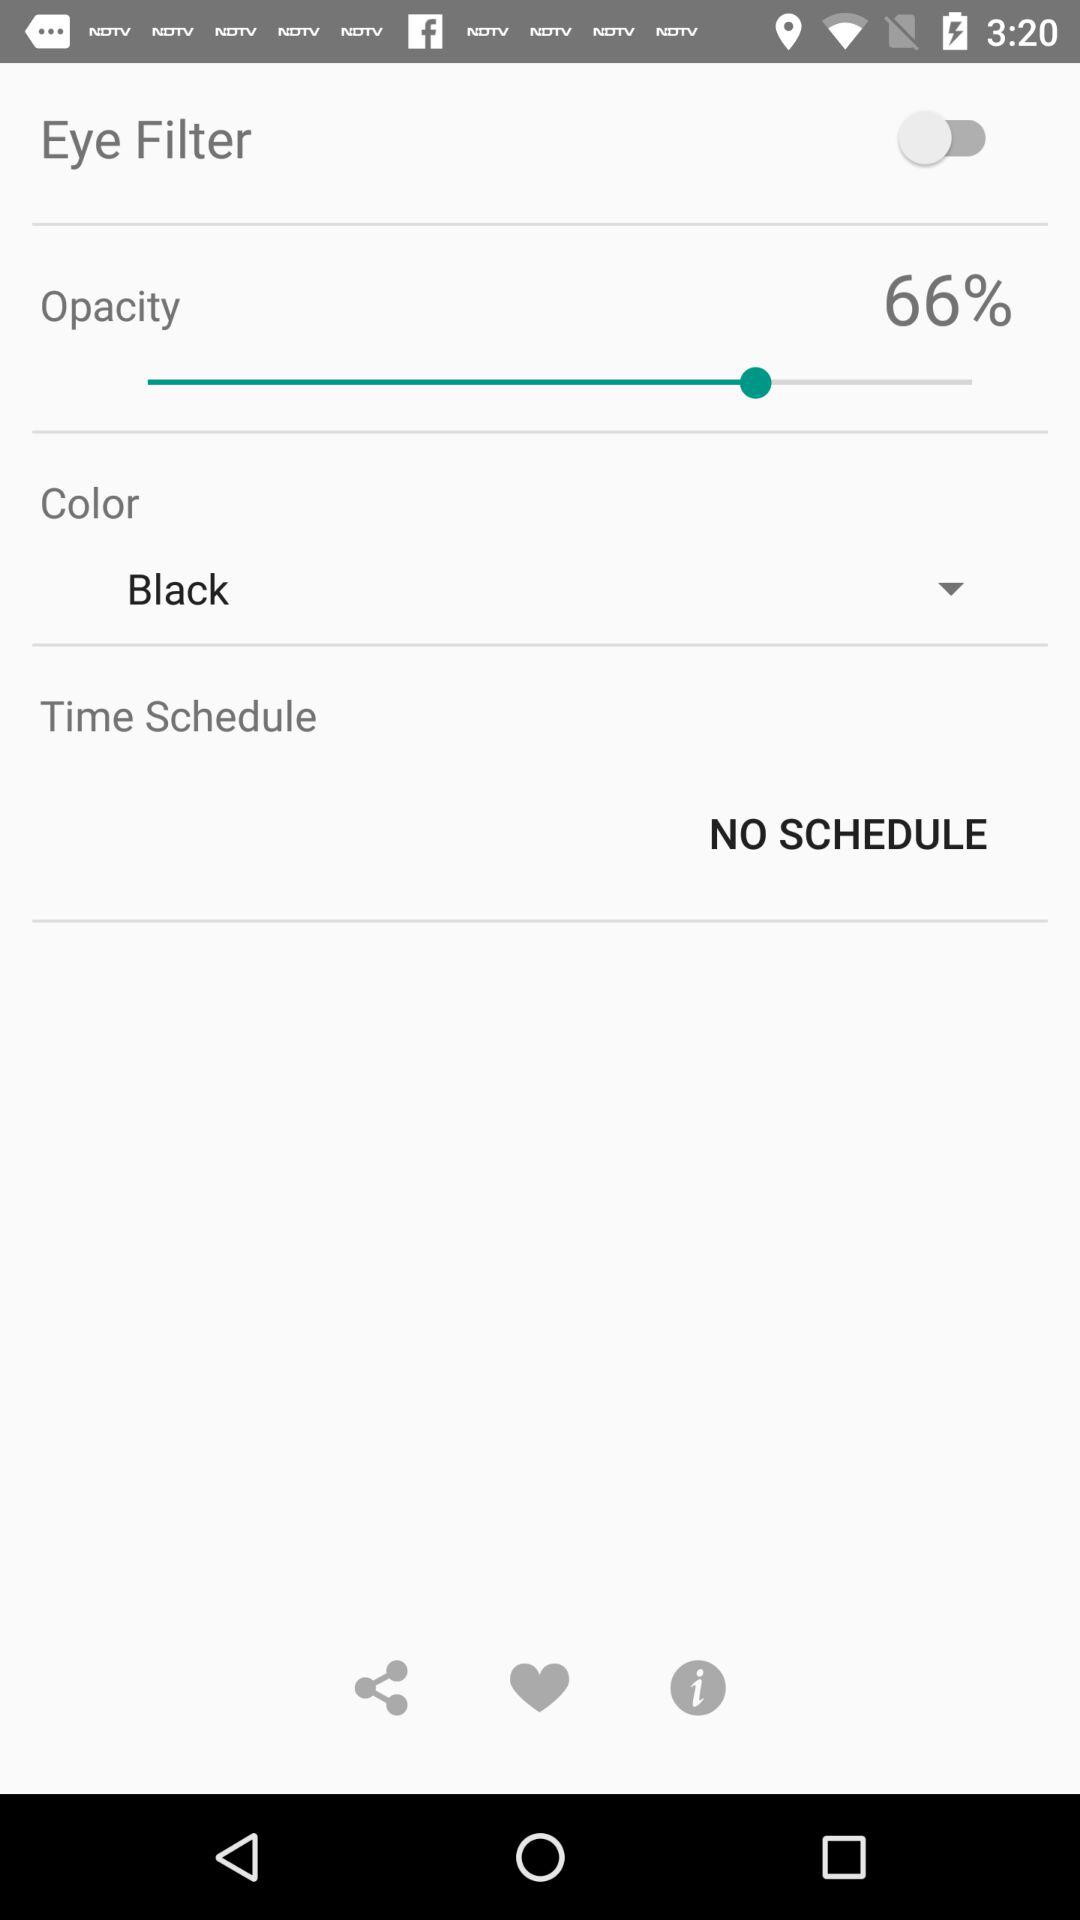What is the capacity has selected?
When the provided information is insufficient, respond with <no answer>. <no answer> 